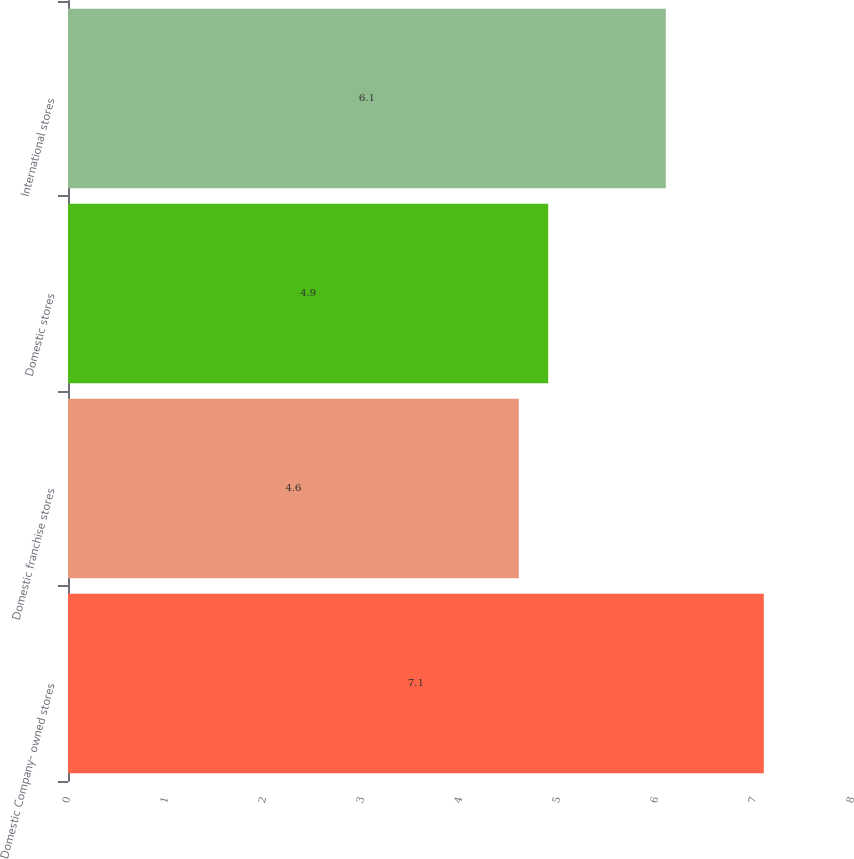Convert chart. <chart><loc_0><loc_0><loc_500><loc_500><bar_chart><fcel>Domestic Company- owned stores<fcel>Domestic franchise stores<fcel>Domestic stores<fcel>International stores<nl><fcel>7.1<fcel>4.6<fcel>4.9<fcel>6.1<nl></chart> 